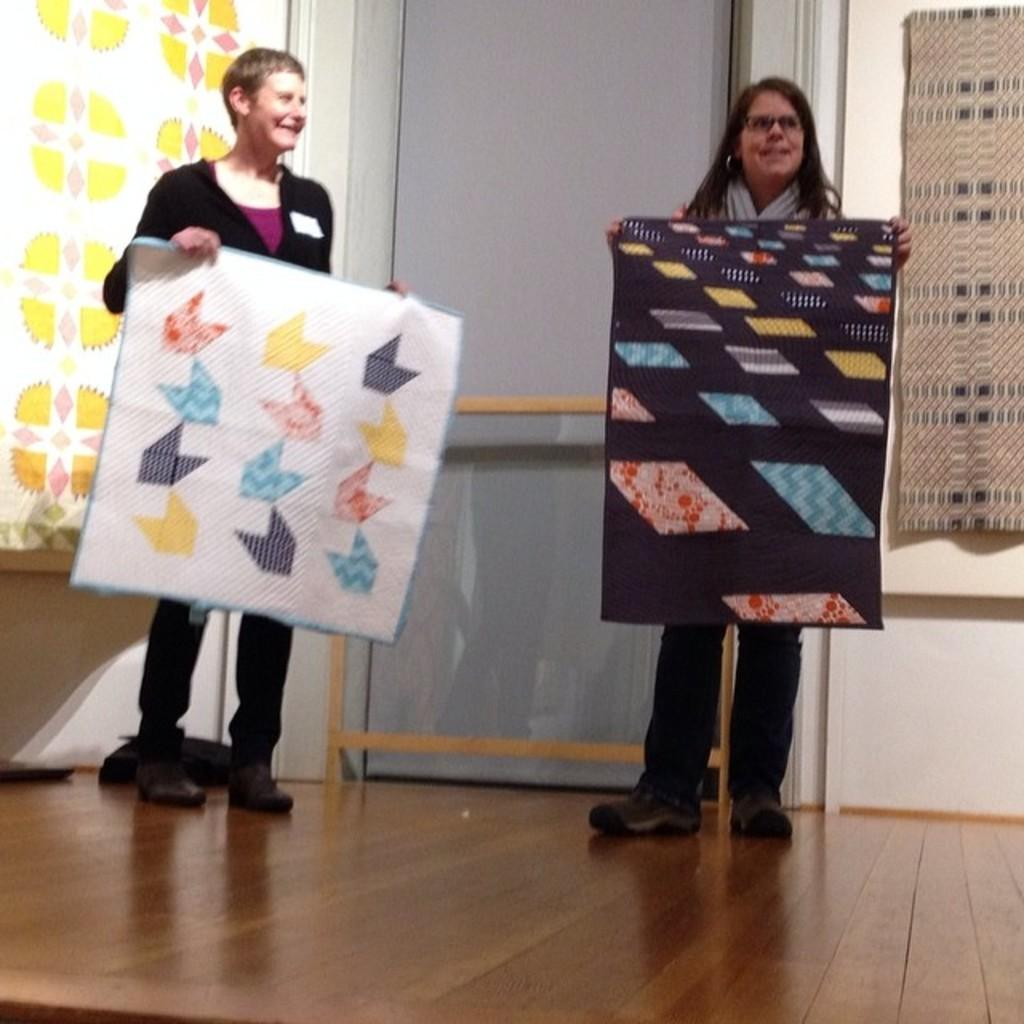What is the position of the woman in the image? There is a woman standing on the left side of the image. What is the woman on the left side wearing? The woman on the left side is wearing a black dress. What is the woman on the left side holding? The woman on the left side is holding a white cloth. Can you describe the other woman in the image? There is another woman standing on the right side of the image. What type of pail is the woman on the left side using to spy on the other woman? There is no pail or spying activity present in the image. 